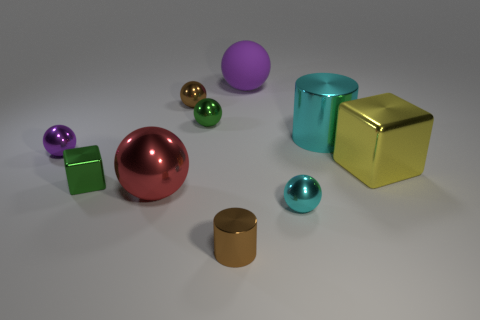Are there the same number of tiny green objects in front of the purple metallic object and brown metallic cylinders behind the big block?
Ensure brevity in your answer.  No. There is a metal object that is the same color as the big cylinder; what shape is it?
Provide a short and direct response. Sphere. There is a cylinder that is behind the small purple ball; is it the same color as the cube that is on the left side of the big red ball?
Your answer should be compact. No. Is the number of cyan things that are on the left side of the large purple rubber thing greater than the number of cyan shiny things?
Your answer should be compact. No. What material is the red object?
Your answer should be very brief. Metal. There is a large red thing that is made of the same material as the small purple object; what is its shape?
Give a very brief answer. Sphere. There is a purple ball that is to the left of the brown shiny object that is in front of the large yellow object; how big is it?
Offer a terse response. Small. What is the color of the large cylinder that is right of the red shiny thing?
Provide a succinct answer. Cyan. Are there any blue objects of the same shape as the big purple object?
Keep it short and to the point. No. Are there fewer small green shiny cubes that are on the right side of the small cyan metallic sphere than small cyan metallic objects on the right side of the tiny cube?
Offer a very short reply. Yes. 